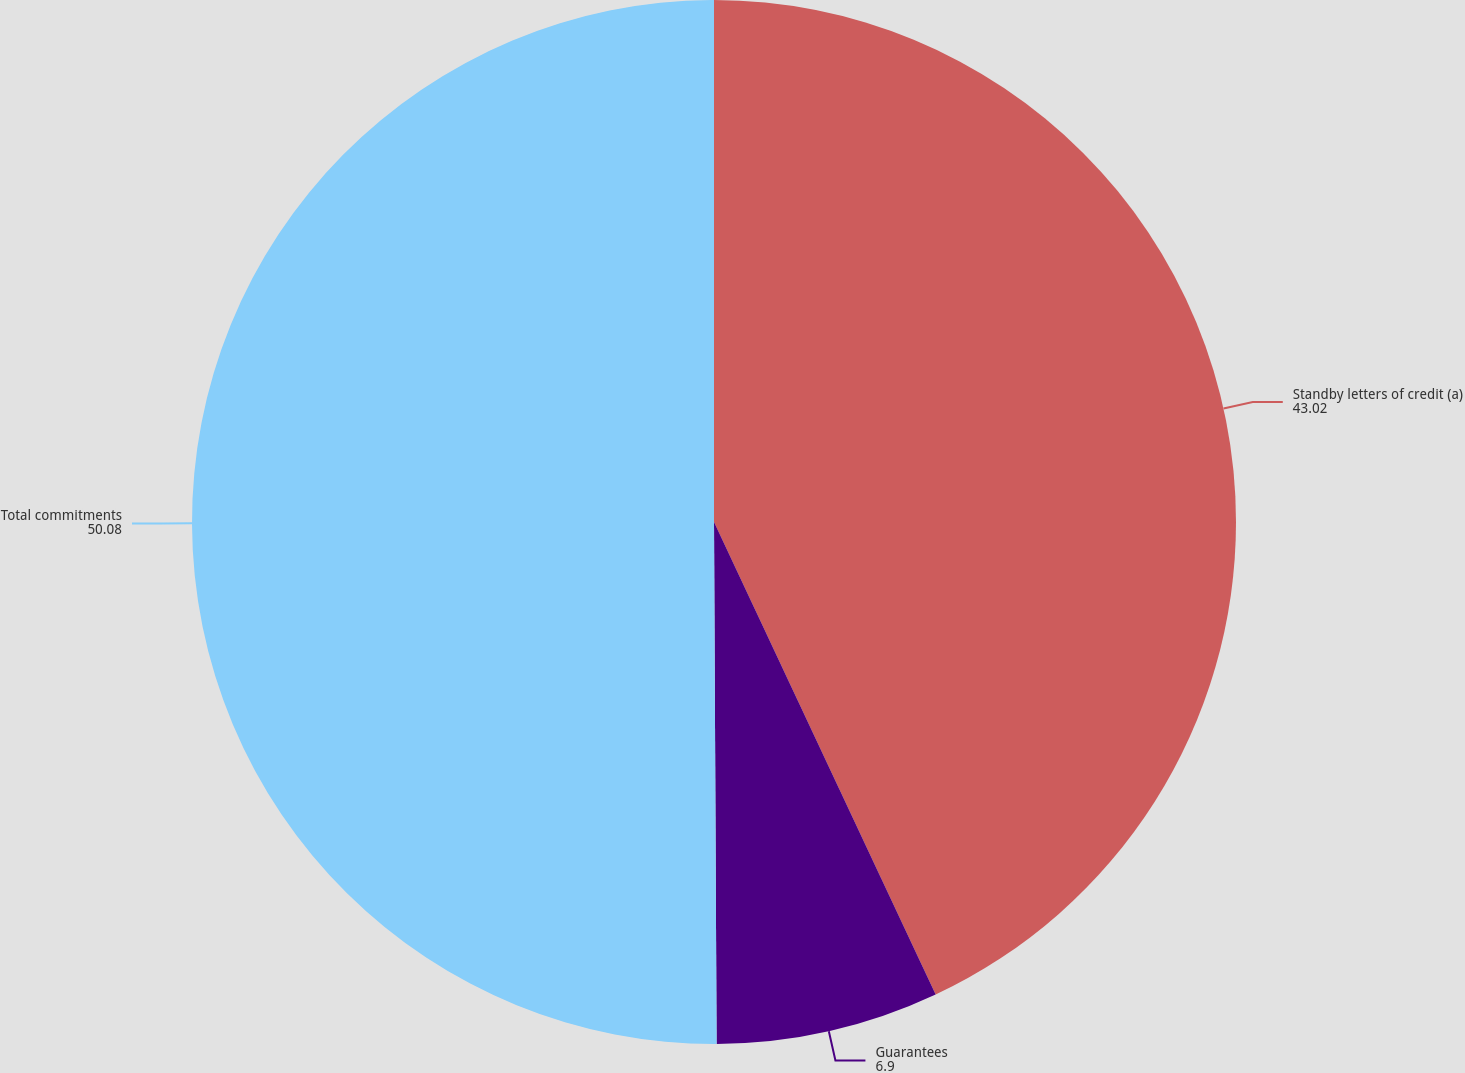<chart> <loc_0><loc_0><loc_500><loc_500><pie_chart><fcel>Standby letters of credit (a)<fcel>Guarantees<fcel>Total commitments<nl><fcel>43.02%<fcel>6.9%<fcel>50.08%<nl></chart> 